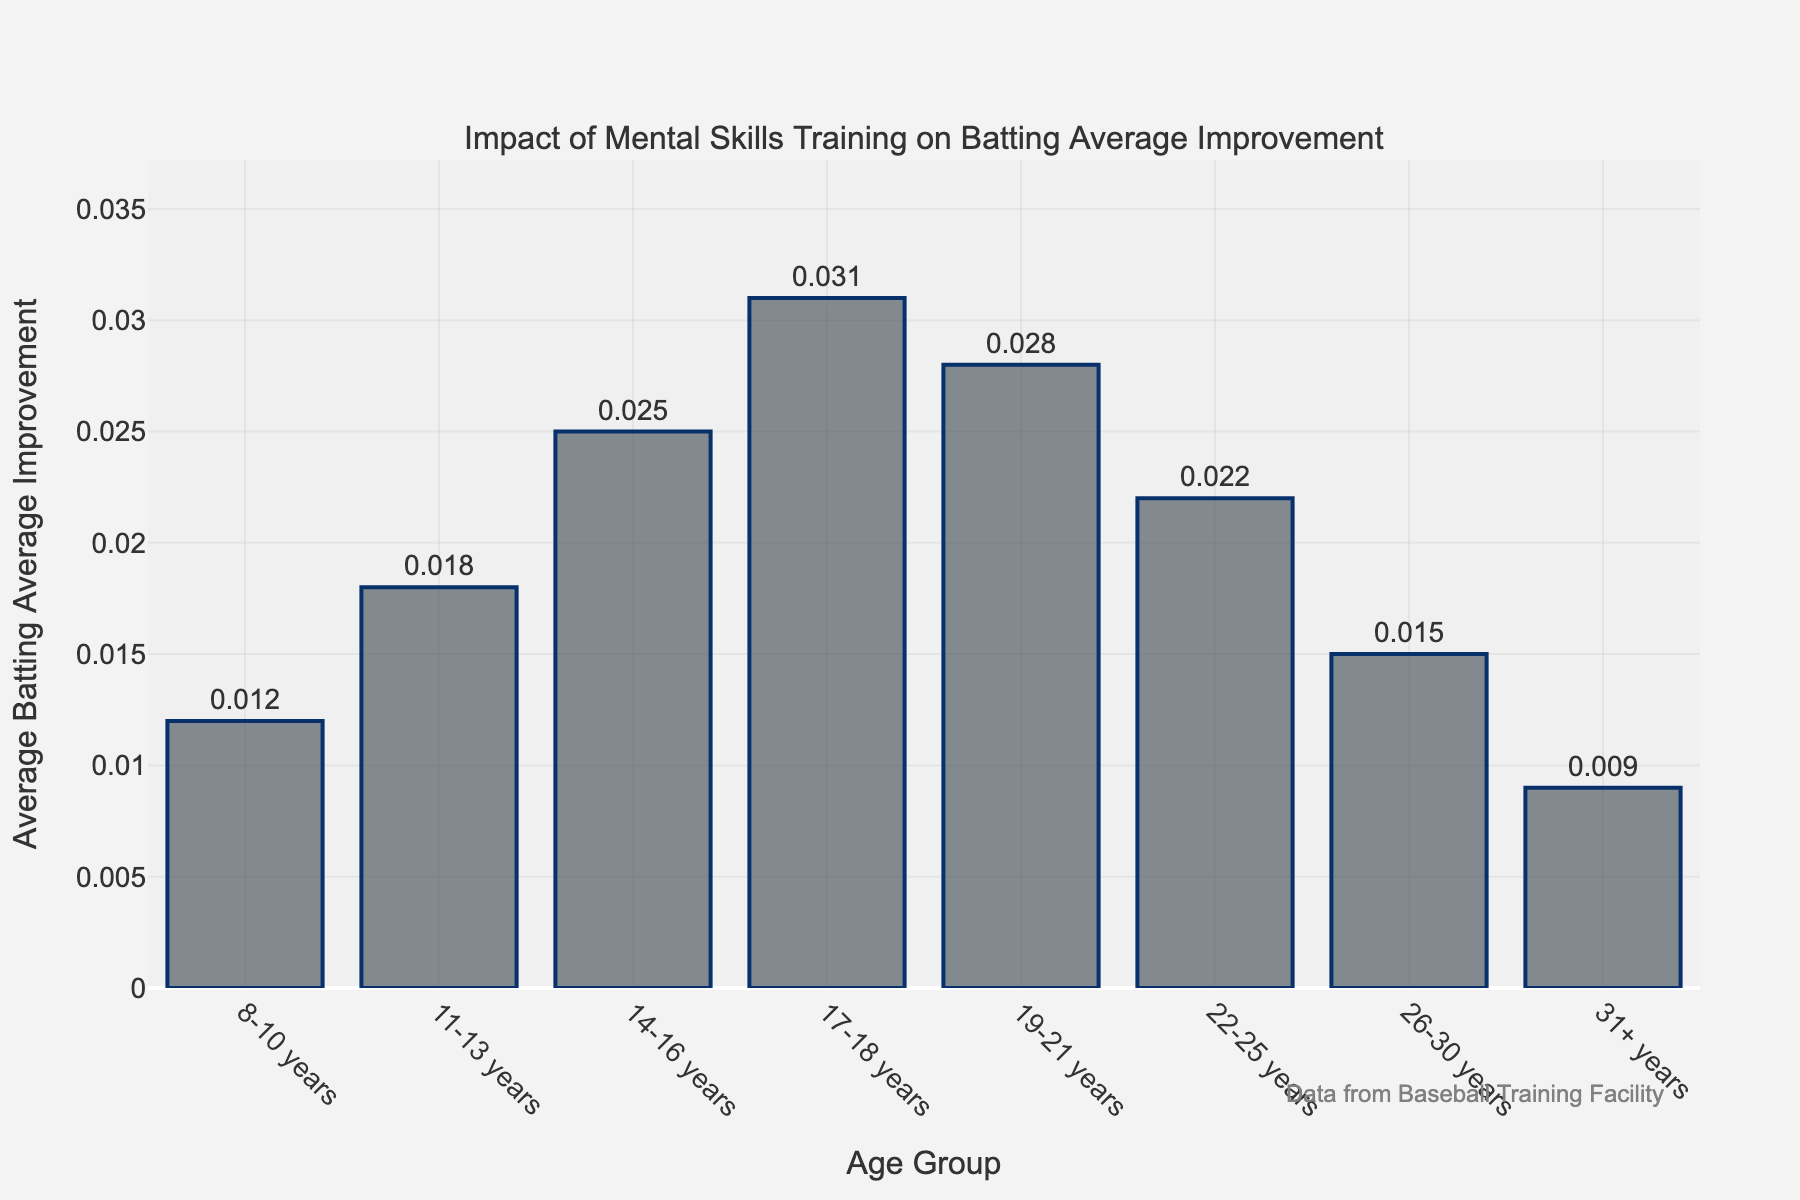What's the age group with the highest average batting average improvement? The age group with the highest batting average improvement has the tallest bar in the plot. By looking at the bar heights, the tallest bar corresponds to the age group of 17-18 years.
Answer: 17-18 years How does the batting average improvement for the 22-25 age group compare to the 8-10 age group? To compare the two, observe the heights of their respective bars. The bar for the 22-25 age group is taller at 0.022 compared to the 0.012 for the 8-10 age group. Therefore, the 22-25 age group has a higher improvement.
Answer: The 22-25 age group has a higher improvement Which age group has the lowest batting average improvement, and what is its value? To find the lowest improvement, look for the shortest bar in the plot. The shortest bar corresponds to the 31+ years age group with a value of 0.009.
Answer: 31+ years, 0.009 What is the total improvement in batting average for all age groups combined? Sum the batting average improvements for each age group: 0.012 + 0.018 + 0.025 + 0.031 + 0.028 + 0.022 + 0.015 + 0.009 = 0.16
Answer: 0.16 How much greater is the batting average improvement for the 14-16 age group compared to the 26-30 age group? Subtract the improvement value of the 26-30 age group from the 14-16 age group: 0.025 - 0.015 = 0.01
Answer: 0.01 Which age groups have an improvement of 0.020 or higher? Identify the bars with heights of 0.020 or more: 11-13 years (0.018 is close but not 0.020), 14-16 years (0.025), 17-18 years (0.031), 19-21 years (0.028), and 22-25 years (0.022). So, the age groups are 14-16, 17-18, 19-21, and 22-25 years.
Answer: 14-16 years, 17-18 years, 19-21 years, 22-25 years What is the average batting average improvement across all age groups? Calculate the average by summing all improvements and then dividing by the number of age groups: Total improvement is 0.16, and there are 8 age groups. So, 0.16 / 8 = 0.02
Answer: 0.02 How many age groups have a batting average improvement higher than 0.02? Count the bars with values greater than 0.02: 14-16 years (0.025), 17-18 years (0.031), 19-21 years (0.028), and 22-25 years (0.022), which gives us 4 age groups.
Answer: 4 